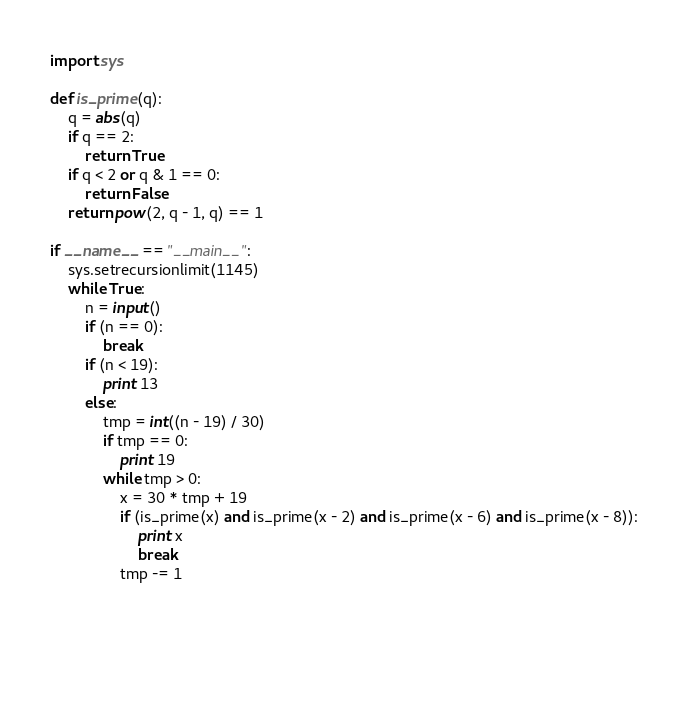Convert code to text. <code><loc_0><loc_0><loc_500><loc_500><_Python_>import sys

def is_prime(q):
    q = abs(q)
    if q == 2:
        return True
    if q < 2 or q & 1 == 0:
        return False
    return pow(2, q - 1, q) == 1
    
if __name__ == "__main__":
    sys.setrecursionlimit(1145)
    while True:
        n = input()
        if (n == 0):
            break
        if (n < 19):
            print 13
        else:
            tmp = int((n - 19) / 30)
            if tmp == 0:
                print 19
            while tmp > 0:
                x = 30 * tmp + 19
                if (is_prime(x) and is_prime(x - 2) and is_prime(x - 6) and is_prime(x - 8)):
                    print x
                    break
                tmp -= 1
            
                
                
                </code> 